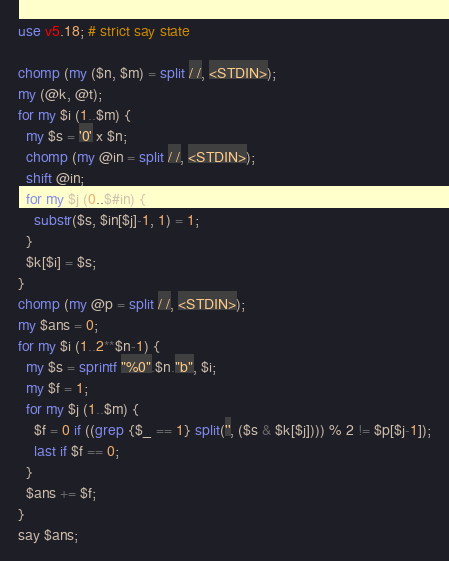Convert code to text. <code><loc_0><loc_0><loc_500><loc_500><_Perl_>use v5.18; # strict say state

chomp (my ($n, $m) = split / /, <STDIN>);
my (@k, @t);
for my $i (1..$m) {
  my $s = '0' x $n;
  chomp (my @in = split / /, <STDIN>);
  shift @in;
  for my $j (0..$#in) {
    substr($s, $in[$j]-1, 1) = 1;
  }
  $k[$i] = $s;
}
chomp (my @p = split / /, <STDIN>);
my $ans = 0;
for my $i (1..2**$n-1) {
  my $s = sprintf "%0".$n."b", $i;
  my $f = 1;
  for my $j (1..$m) {
    $f = 0 if ((grep {$_ == 1} split('', ($s & $k[$j]))) % 2 != $p[$j-1]);
    last if $f == 0;
  }
  $ans += $f;
}
say $ans;</code> 